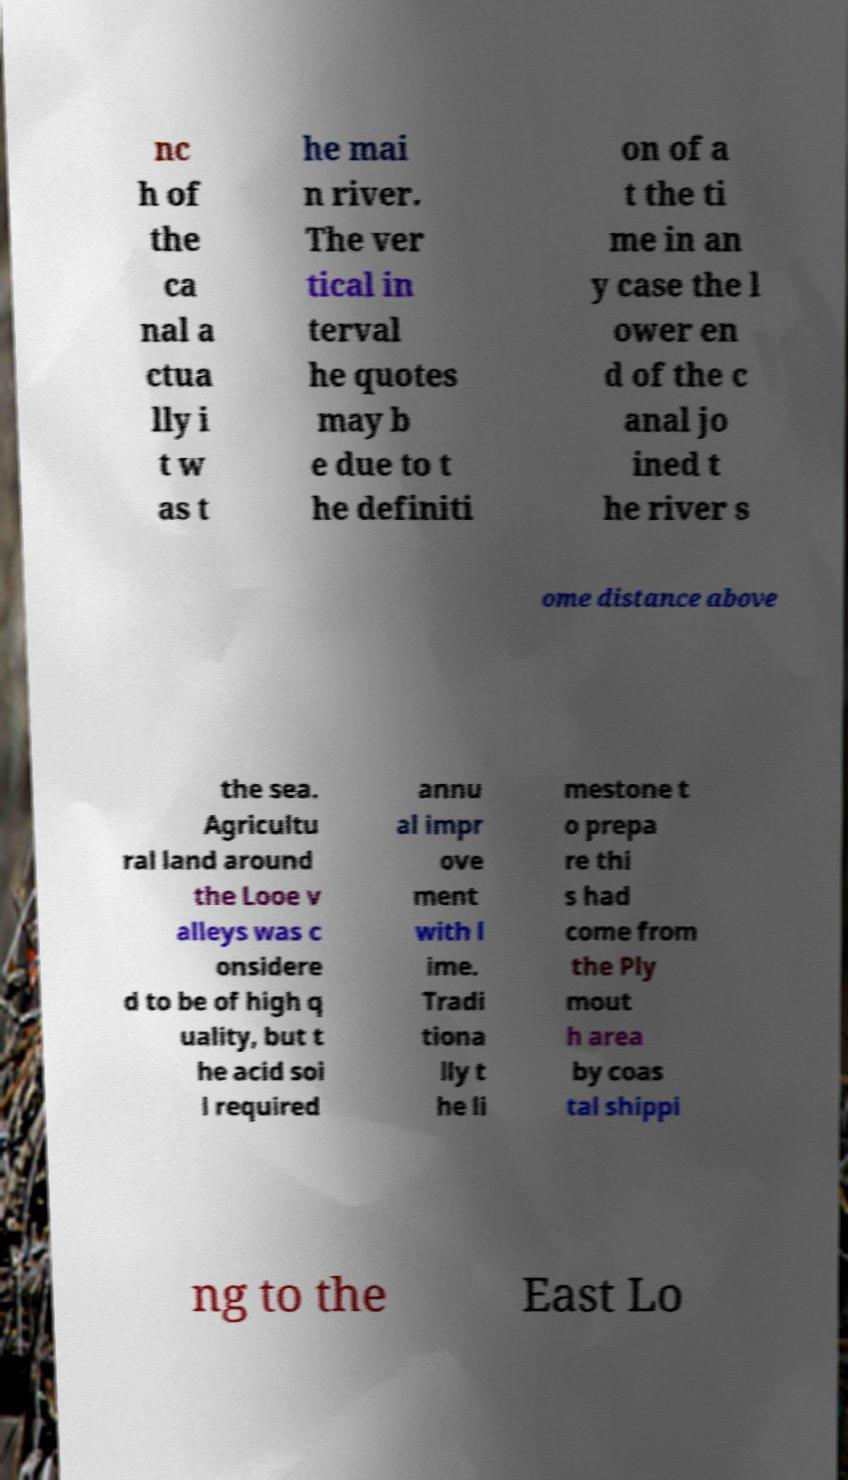Could you extract and type out the text from this image? nc h of the ca nal a ctua lly i t w as t he mai n river. The ver tical in terval he quotes may b e due to t he definiti on of a t the ti me in an y case the l ower en d of the c anal jo ined t he river s ome distance above the sea. Agricultu ral land around the Looe v alleys was c onsidere d to be of high q uality, but t he acid soi l required annu al impr ove ment with l ime. Tradi tiona lly t he li mestone t o prepa re thi s had come from the Ply mout h area by coas tal shippi ng to the East Lo 